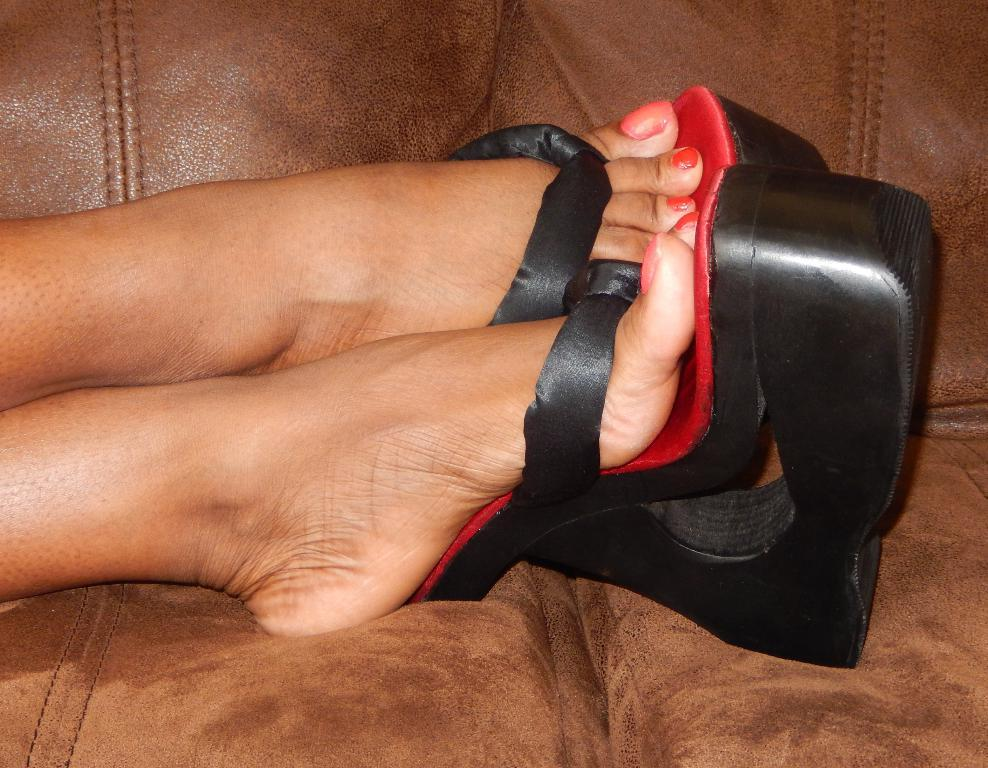What color footwear is the person in the image wearing? The person in the image is wearing black and red color footwear. What type of furniture is the person sitting on? The person is sitting on a brown color couch. How many hills can be seen in the background of the image? There are no hills visible in the image; it only shows a person sitting on a brown color couch. What type of rice is being cooked in the image? There is no rice present in the image. 